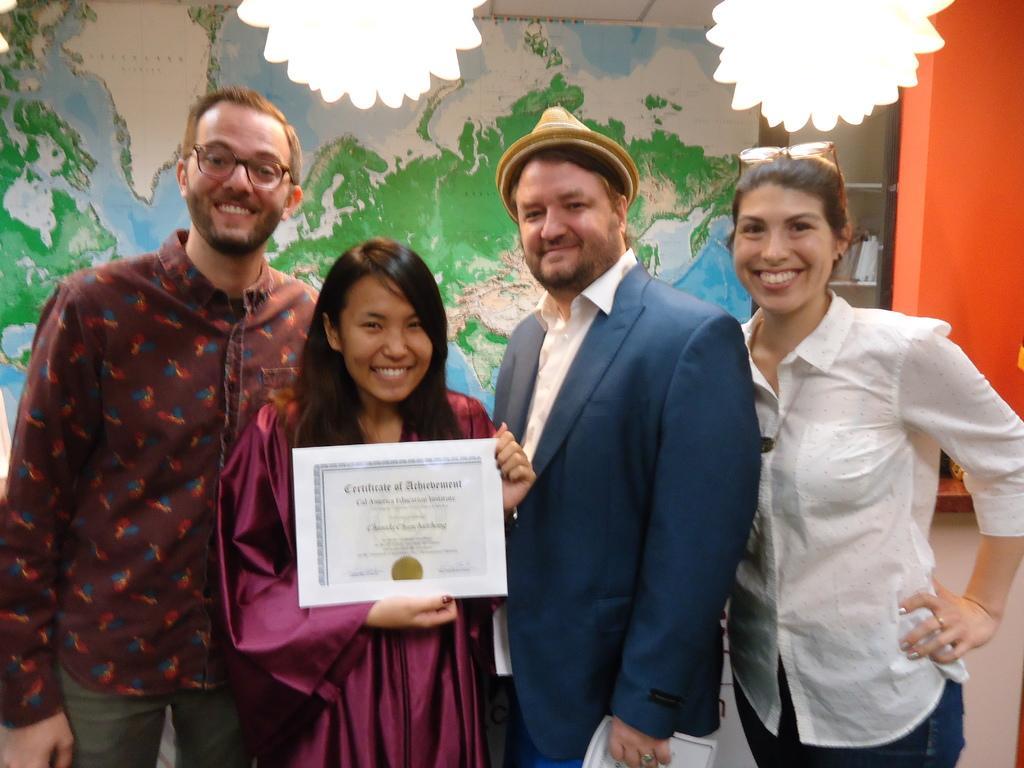Describe this image in one or two sentences. In this image I can see a woman is holding the certificate in her hand and laughing, she wore dark red color dress. 2 Men are standing on either side of her, on the right side a woman is smiling, she wore white color shirt. Behind them there is the world map painting on a wall. 